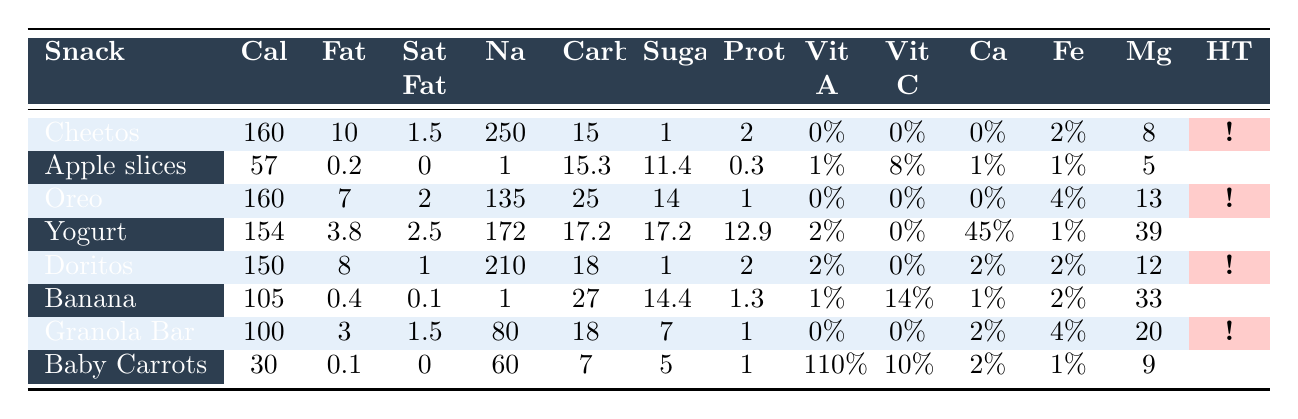What is the calorie content of Cheetos Crunchy? The table shows that the calories for Cheetos Crunchy are listed as 160.
Answer: 160 Which snack has the highest sodium content? By comparing the sodium values in the table, Cheetos Crunchy has the highest at 250 mg.
Answer: Cheetos Crunchy Does Yogurt (low-fat, plain) have any sugar? The table indicates that Yogurt (low-fat, plain) has 17.2 grams of sugar.
Answer: Yes How much protein does a Banana have compared to Oreo Cookies? Bananas have 1.3 grams of protein, while Oreo Cookies have 1 gram. Banana has more protein, specifically 0.3 grams more.
Answer: Banana Which snack has the lowest calories, and what is its calorie count? The snack with the lowest calories is Baby Carrots, with 30 calories.
Answer: 30 Is potential headache trigger indicated for all snacks? By examining the table, it shows that not all snacks are potential headache triggers, specifically Apple slices, Yogurt, Banana, and Baby Carrots are not.
Answer: No What is the total sugar content of the snacks that are potential headache triggers? Adding the sugar values for Cheetos (1g), Oreo (14g), Doritos (1g), Chocolate Chip Granola Bar (7g) gives 23g.
Answer: 23g Which snack provides the highest percentage of Vitamin A? The highest percentage of Vitamin A is provided by Baby Carrots at 110%.
Answer: Baby Carrots What is the difference in total carbohydrates between Doritos Nacho Cheese and Apple slices? Doritos Nacho Cheese has 18 grams of carbs, and Apple slices have 15.3 grams. The difference is 18 - 15.3 = 2.7 grams.
Answer: 2.7 grams Are there any snacks in the table that provide more than 20% calcium? The table shows that Yogurt provides 45% calcium, which is more than 20%. Thus, at least one snack does exceed that threshold.
Answer: Yes 